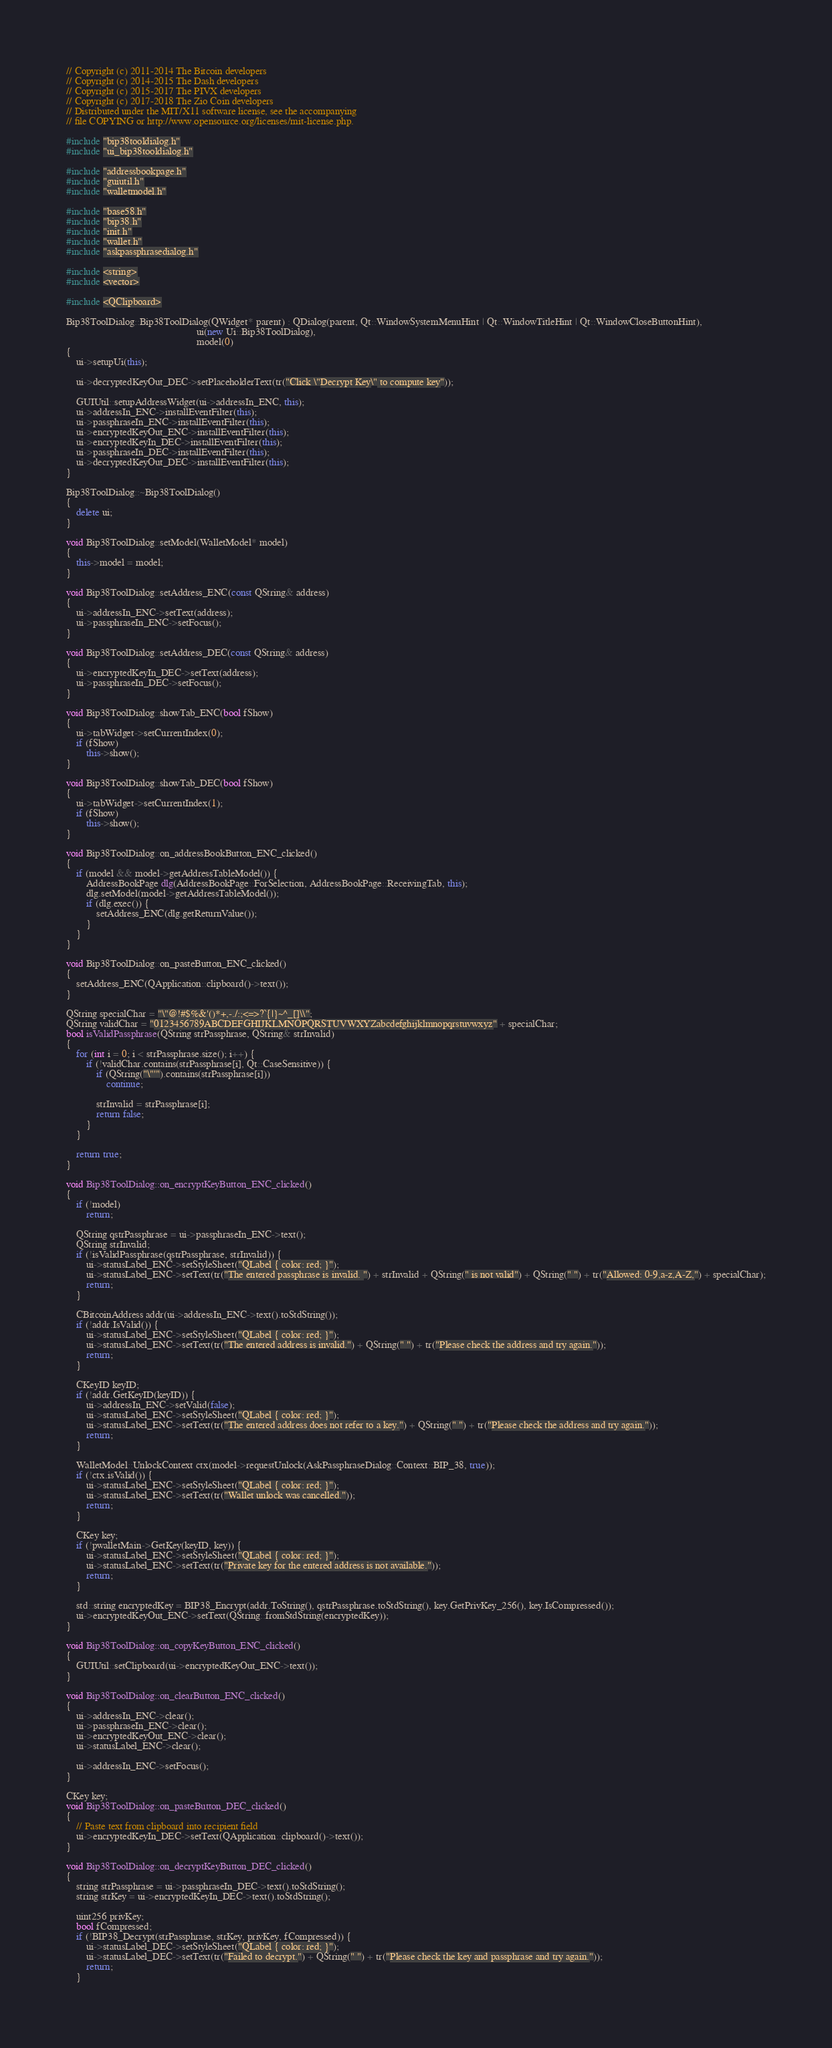Convert code to text. <code><loc_0><loc_0><loc_500><loc_500><_C++_>// Copyright (c) 2011-2014 The Bitcoin developers
// Copyright (c) 2014-2015 The Dash developers
// Copyright (c) 2015-2017 The PIVX developers
// Copyright (c) 2017-2018 The Zio Coin developers
// Distributed under the MIT/X11 software license, see the accompanying
// file COPYING or http://www.opensource.org/licenses/mit-license.php.

#include "bip38tooldialog.h"
#include "ui_bip38tooldialog.h"

#include "addressbookpage.h"
#include "guiutil.h"
#include "walletmodel.h"

#include "base58.h"
#include "bip38.h"
#include "init.h"
#include "wallet.h"
#include "askpassphrasedialog.h"

#include <string>
#include <vector>

#include <QClipboard>

Bip38ToolDialog::Bip38ToolDialog(QWidget* parent) : QDialog(parent, Qt::WindowSystemMenuHint | Qt::WindowTitleHint | Qt::WindowCloseButtonHint),
                                                    ui(new Ui::Bip38ToolDialog),
                                                    model(0)
{
    ui->setupUi(this);

    ui->decryptedKeyOut_DEC->setPlaceholderText(tr("Click \"Decrypt Key\" to compute key"));

    GUIUtil::setupAddressWidget(ui->addressIn_ENC, this);
    ui->addressIn_ENC->installEventFilter(this);
    ui->passphraseIn_ENC->installEventFilter(this);
    ui->encryptedKeyOut_ENC->installEventFilter(this);
    ui->encryptedKeyIn_DEC->installEventFilter(this);
    ui->passphraseIn_DEC->installEventFilter(this);
    ui->decryptedKeyOut_DEC->installEventFilter(this);
}

Bip38ToolDialog::~Bip38ToolDialog()
{
    delete ui;
}

void Bip38ToolDialog::setModel(WalletModel* model)
{
    this->model = model;
}

void Bip38ToolDialog::setAddress_ENC(const QString& address)
{
    ui->addressIn_ENC->setText(address);
    ui->passphraseIn_ENC->setFocus();
}

void Bip38ToolDialog::setAddress_DEC(const QString& address)
{
    ui->encryptedKeyIn_DEC->setText(address);
    ui->passphraseIn_DEC->setFocus();
}

void Bip38ToolDialog::showTab_ENC(bool fShow)
{
    ui->tabWidget->setCurrentIndex(0);
    if (fShow)
        this->show();
}

void Bip38ToolDialog::showTab_DEC(bool fShow)
{
    ui->tabWidget->setCurrentIndex(1);
    if (fShow)
        this->show();
}

void Bip38ToolDialog::on_addressBookButton_ENC_clicked()
{
    if (model && model->getAddressTableModel()) {
        AddressBookPage dlg(AddressBookPage::ForSelection, AddressBookPage::ReceivingTab, this);
        dlg.setModel(model->getAddressTableModel());
        if (dlg.exec()) {
            setAddress_ENC(dlg.getReturnValue());
        }
    }
}

void Bip38ToolDialog::on_pasteButton_ENC_clicked()
{
    setAddress_ENC(QApplication::clipboard()->text());
}

QString specialChar = "\"@!#$%&'()*+,-./:;<=>?`{|}~^_[]\\";
QString validChar = "0123456789ABCDEFGHIJKLMNOPQRSTUVWXYZabcdefghijklmnopqrstuvwxyz" + specialChar;
bool isValidPassphrase(QString strPassphrase, QString& strInvalid)
{
    for (int i = 0; i < strPassphrase.size(); i++) {
        if (!validChar.contains(strPassphrase[i], Qt::CaseSensitive)) {
            if (QString("\"'").contains(strPassphrase[i]))
                continue;

            strInvalid = strPassphrase[i];
            return false;
        }
    }

    return true;
}

void Bip38ToolDialog::on_encryptKeyButton_ENC_clicked()
{
    if (!model)
        return;

    QString qstrPassphrase = ui->passphraseIn_ENC->text();
    QString strInvalid;
    if (!isValidPassphrase(qstrPassphrase, strInvalid)) {
        ui->statusLabel_ENC->setStyleSheet("QLabel { color: red; }");
        ui->statusLabel_ENC->setText(tr("The entered passphrase is invalid. ") + strInvalid + QString(" is not valid") + QString(" ") + tr("Allowed: 0-9,a-z,A-Z,") + specialChar);
        return;
    }

    CBitcoinAddress addr(ui->addressIn_ENC->text().toStdString());
    if (!addr.IsValid()) {
        ui->statusLabel_ENC->setStyleSheet("QLabel { color: red; }");
        ui->statusLabel_ENC->setText(tr("The entered address is invalid.") + QString(" ") + tr("Please check the address and try again."));
        return;
    }

    CKeyID keyID;
    if (!addr.GetKeyID(keyID)) {
        ui->addressIn_ENC->setValid(false);
        ui->statusLabel_ENC->setStyleSheet("QLabel { color: red; }");
        ui->statusLabel_ENC->setText(tr("The entered address does not refer to a key.") + QString(" ") + tr("Please check the address and try again."));
        return;
    }

    WalletModel::UnlockContext ctx(model->requestUnlock(AskPassphraseDialog::Context::BIP_38, true));
    if (!ctx.isValid()) {
        ui->statusLabel_ENC->setStyleSheet("QLabel { color: red; }");
        ui->statusLabel_ENC->setText(tr("Wallet unlock was cancelled."));
        return;
    }

    CKey key;
    if (!pwalletMain->GetKey(keyID, key)) {
        ui->statusLabel_ENC->setStyleSheet("QLabel { color: red; }");
        ui->statusLabel_ENC->setText(tr("Private key for the entered address is not available."));
        return;
    }

    std::string encryptedKey = BIP38_Encrypt(addr.ToString(), qstrPassphrase.toStdString(), key.GetPrivKey_256(), key.IsCompressed());
    ui->encryptedKeyOut_ENC->setText(QString::fromStdString(encryptedKey));
}

void Bip38ToolDialog::on_copyKeyButton_ENC_clicked()
{
    GUIUtil::setClipboard(ui->encryptedKeyOut_ENC->text());
}

void Bip38ToolDialog::on_clearButton_ENC_clicked()
{
    ui->addressIn_ENC->clear();
    ui->passphraseIn_ENC->clear();
    ui->encryptedKeyOut_ENC->clear();
    ui->statusLabel_ENC->clear();

    ui->addressIn_ENC->setFocus();
}

CKey key;
void Bip38ToolDialog::on_pasteButton_DEC_clicked()
{
    // Paste text from clipboard into recipient field
    ui->encryptedKeyIn_DEC->setText(QApplication::clipboard()->text());
}

void Bip38ToolDialog::on_decryptKeyButton_DEC_clicked()
{
    string strPassphrase = ui->passphraseIn_DEC->text().toStdString();
    string strKey = ui->encryptedKeyIn_DEC->text().toStdString();

    uint256 privKey;
    bool fCompressed;
    if (!BIP38_Decrypt(strPassphrase, strKey, privKey, fCompressed)) {
        ui->statusLabel_DEC->setStyleSheet("QLabel { color: red; }");
        ui->statusLabel_DEC->setText(tr("Failed to decrypt.") + QString(" ") + tr("Please check the key and passphrase and try again."));
        return;
    }
</code> 